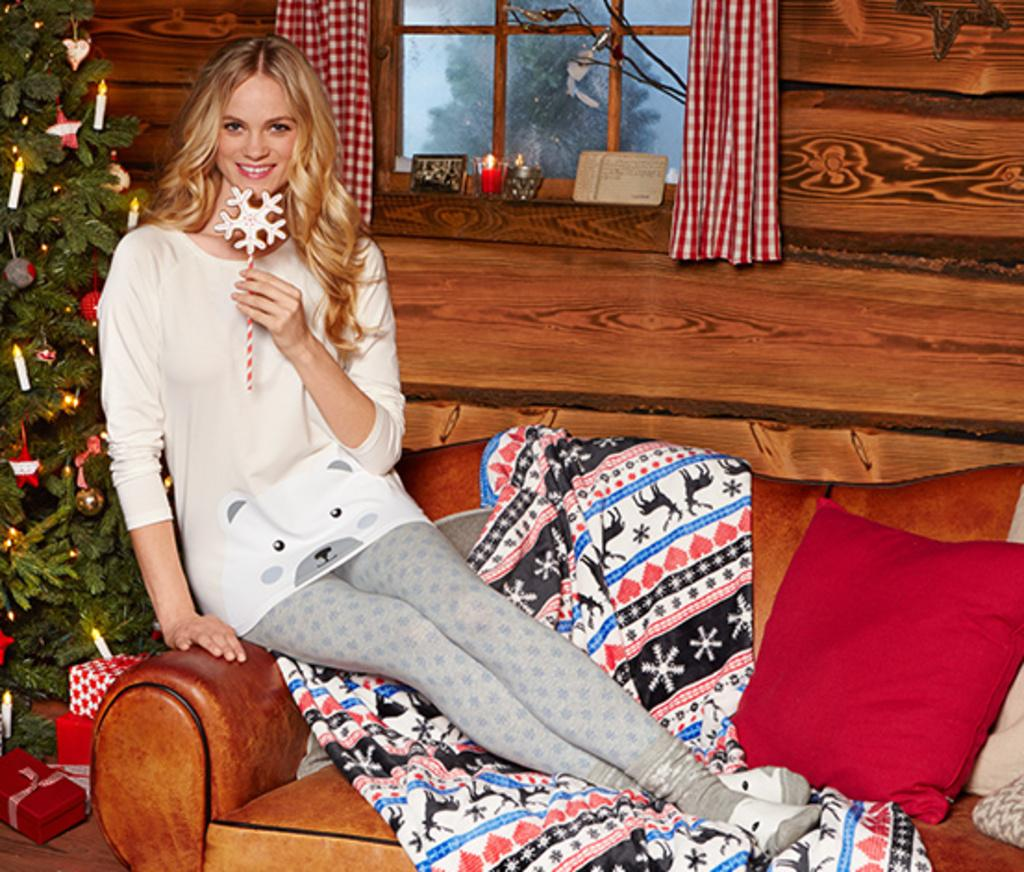What is the person in the image doing? There is a person on the couch in the image. What is covering the couch? There is a blanket on the couch, and there are pillows on the couch as well. What can be seen in the background of the image? There is a Christmas tree in the image, and there is a window with curtains associated with it. What is the wall in the image like? There is a wall visible in the image. What other objects can be seen in the room? There are various objects around the room. Can you hear the person whistling in the image? There is no indication of sound in the image, so it is not possible to determine if the person is whistling or not. 